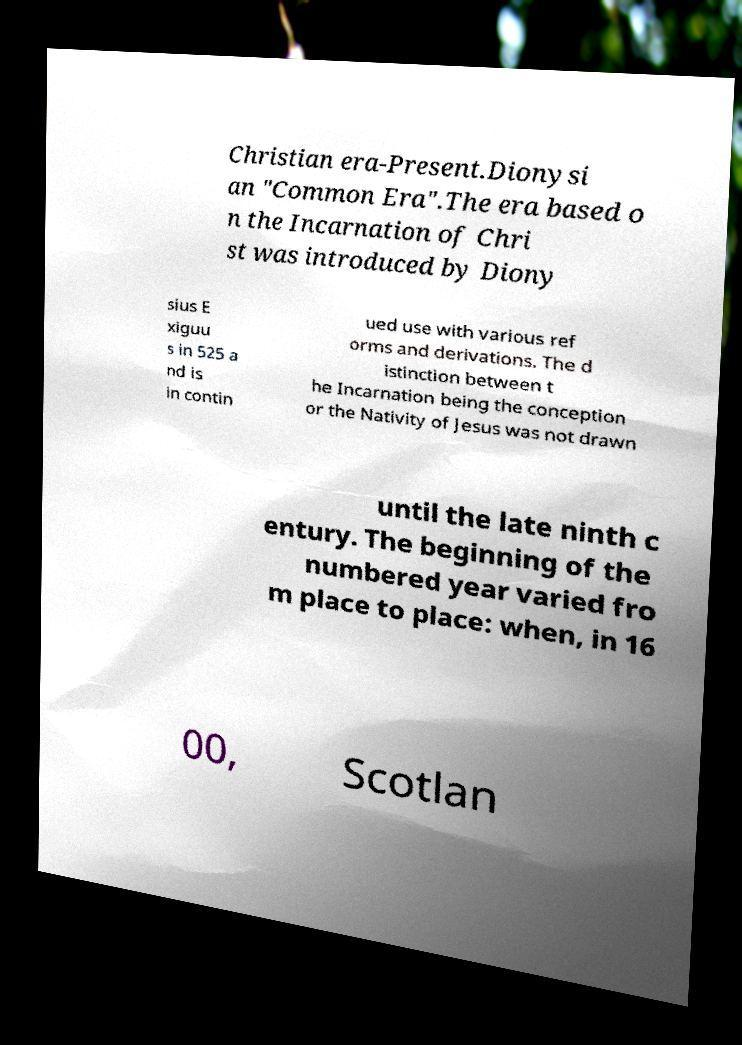Could you extract and type out the text from this image? Christian era-Present.Dionysi an "Common Era".The era based o n the Incarnation of Chri st was introduced by Diony sius E xiguu s in 525 a nd is in contin ued use with various ref orms and derivations. The d istinction between t he Incarnation being the conception or the Nativity of Jesus was not drawn until the late ninth c entury. The beginning of the numbered year varied fro m place to place: when, in 16 00, Scotlan 